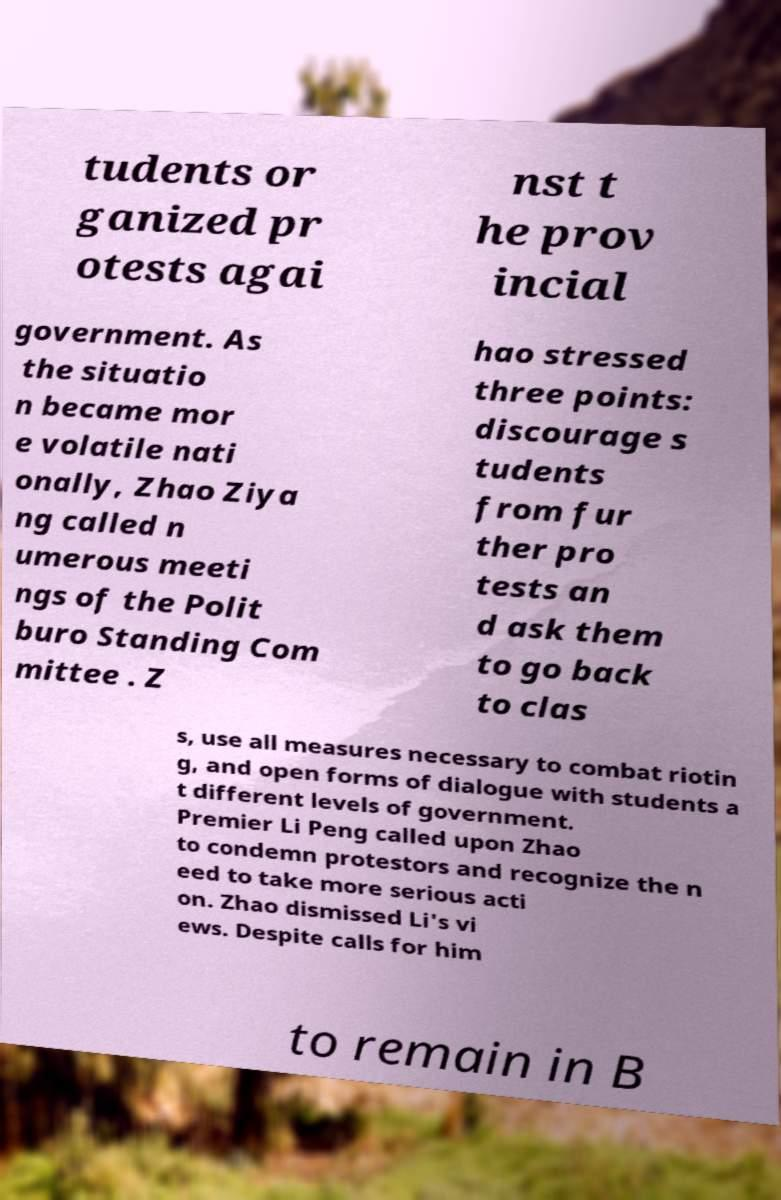I need the written content from this picture converted into text. Can you do that? tudents or ganized pr otests agai nst t he prov incial government. As the situatio n became mor e volatile nati onally, Zhao Ziya ng called n umerous meeti ngs of the Polit buro Standing Com mittee . Z hao stressed three points: discourage s tudents from fur ther pro tests an d ask them to go back to clas s, use all measures necessary to combat riotin g, and open forms of dialogue with students a t different levels of government. Premier Li Peng called upon Zhao to condemn protestors and recognize the n eed to take more serious acti on. Zhao dismissed Li's vi ews. Despite calls for him to remain in B 